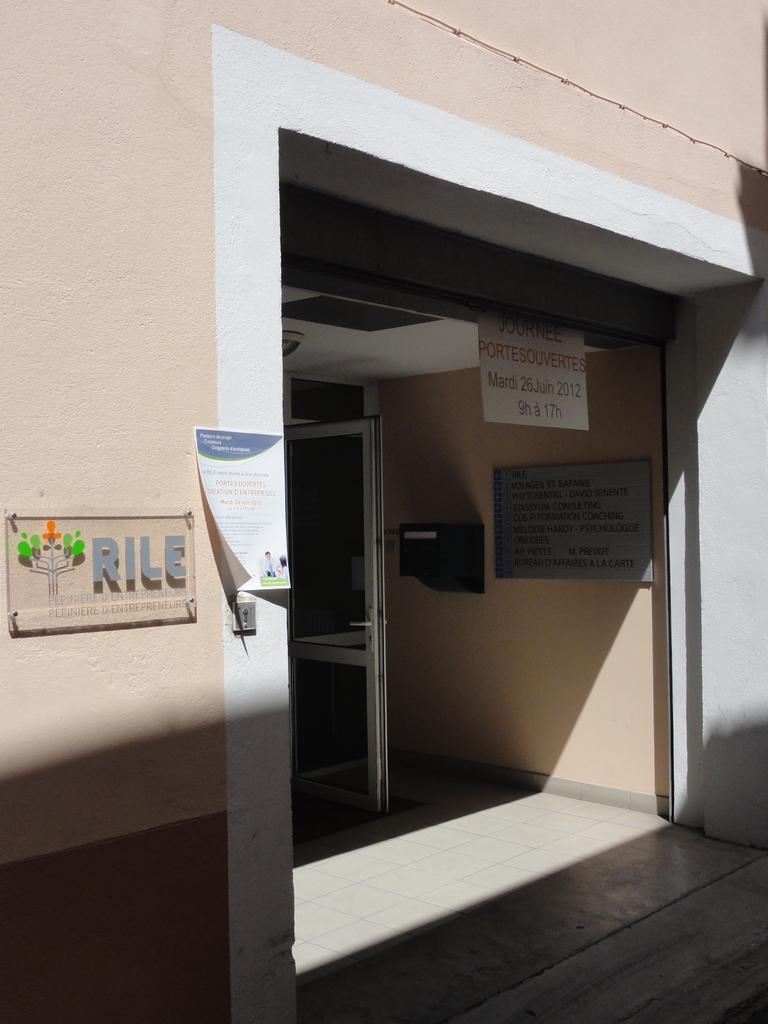Describe this image in one or two sentences. In this image there is a building in the middle. At the bottom there is the entrance with two doors. On the left side there is a board on the wall. 